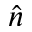<formula> <loc_0><loc_0><loc_500><loc_500>\hat { n }</formula> 